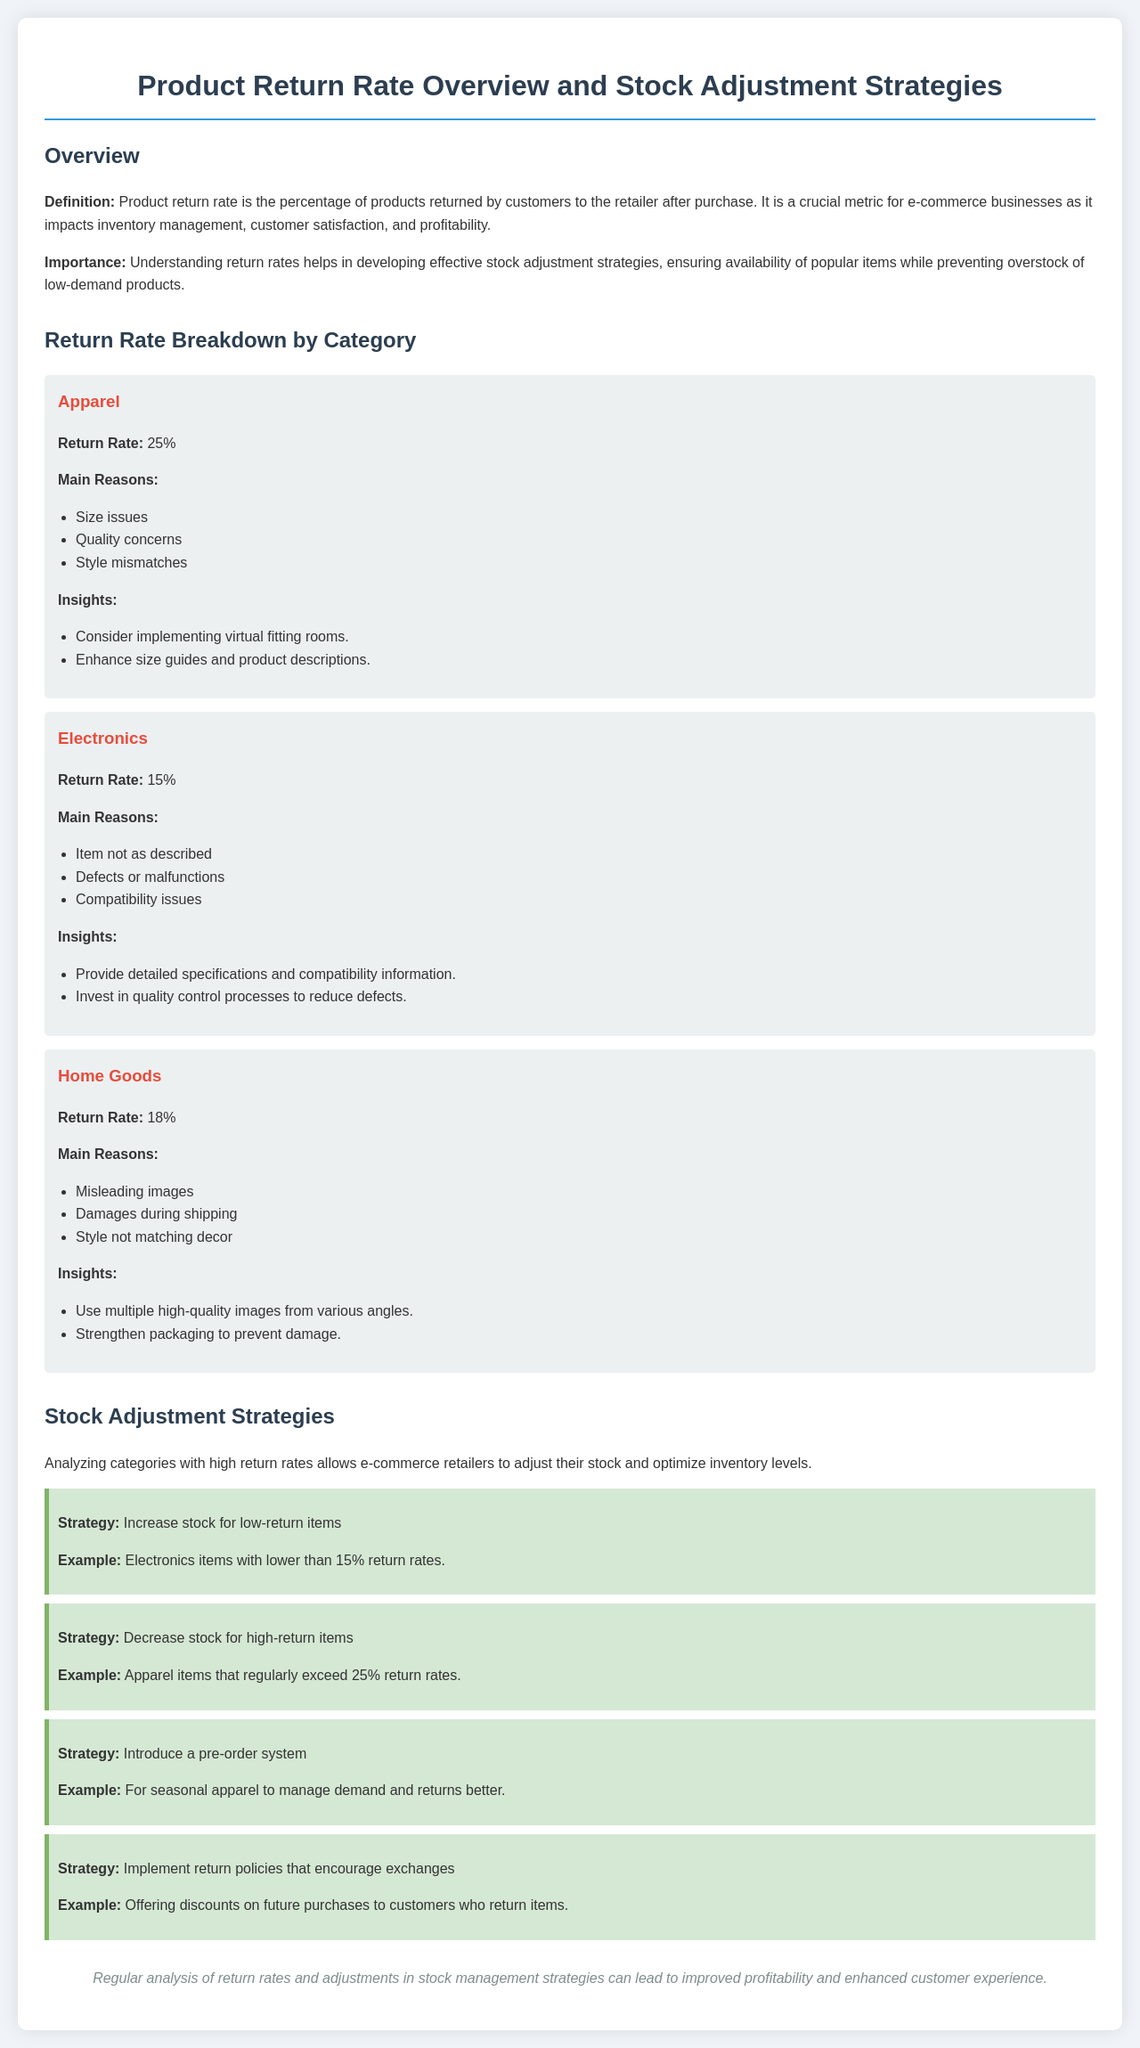What is the return rate for Apparel? The return rate for Apparel is specifically mentioned in the document as 25%.
Answer: 25% What are the main reasons for returns in Electronics? The document lists three reasons: item not as described, defects or malfunctions, and compatibility issues.
Answer: Item not as described, defects or malfunctions, compatibility issues What strategy is suggested for high-return items? The document advises to decrease stock for high-return items.
Answer: Decrease stock for high-return items What is the return rate for Home Goods? The return rate for Home Goods is explicitly stated in the document as 18%.
Answer: 18% What is a suggested strategy for managing seasonal apparel? The document recommends introducing a pre-order system as a strategy.
Answer: Introduce a pre-order system What is the definition of product return rate? The document defines product return rate as the percentage of products returned by customers to the retailer after purchase.
Answer: Percentage of products returned by customers to the retailer after purchase What is the main reason for the high return rate in Apparel? The primary reason listed for high return rates in Apparel is size issues.
Answer: Size issues How can quality concerns in Apparel be addressed? The document suggests enhancing size guides and product descriptions to address quality concerns.
Answer: Enhance size guides and product descriptions What should retailers do for items with lower than 15% return rates? Retailers are advised to increase stock for items with lower than 15% return rates.
Answer: Increase stock for low-return items 